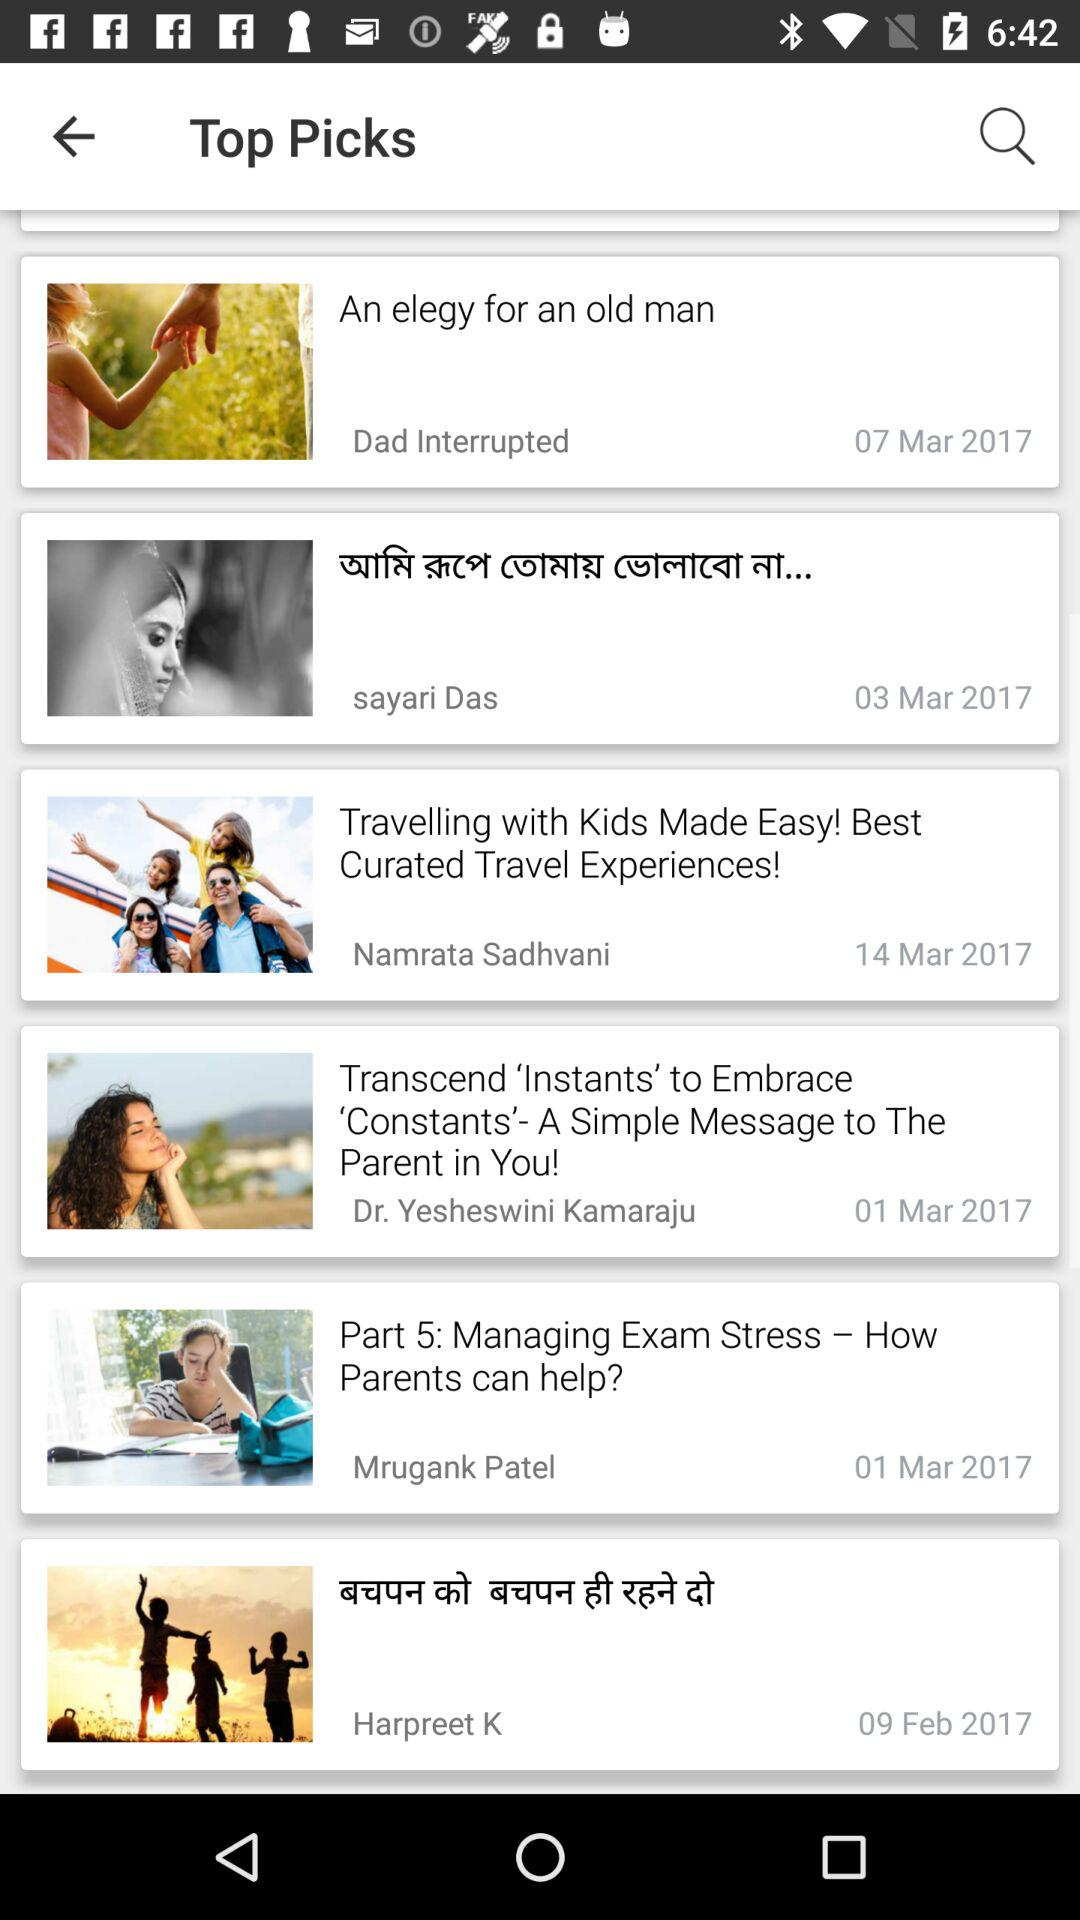What is the date of the article "An elegy for an old man"? The date is March 7, 2017. 